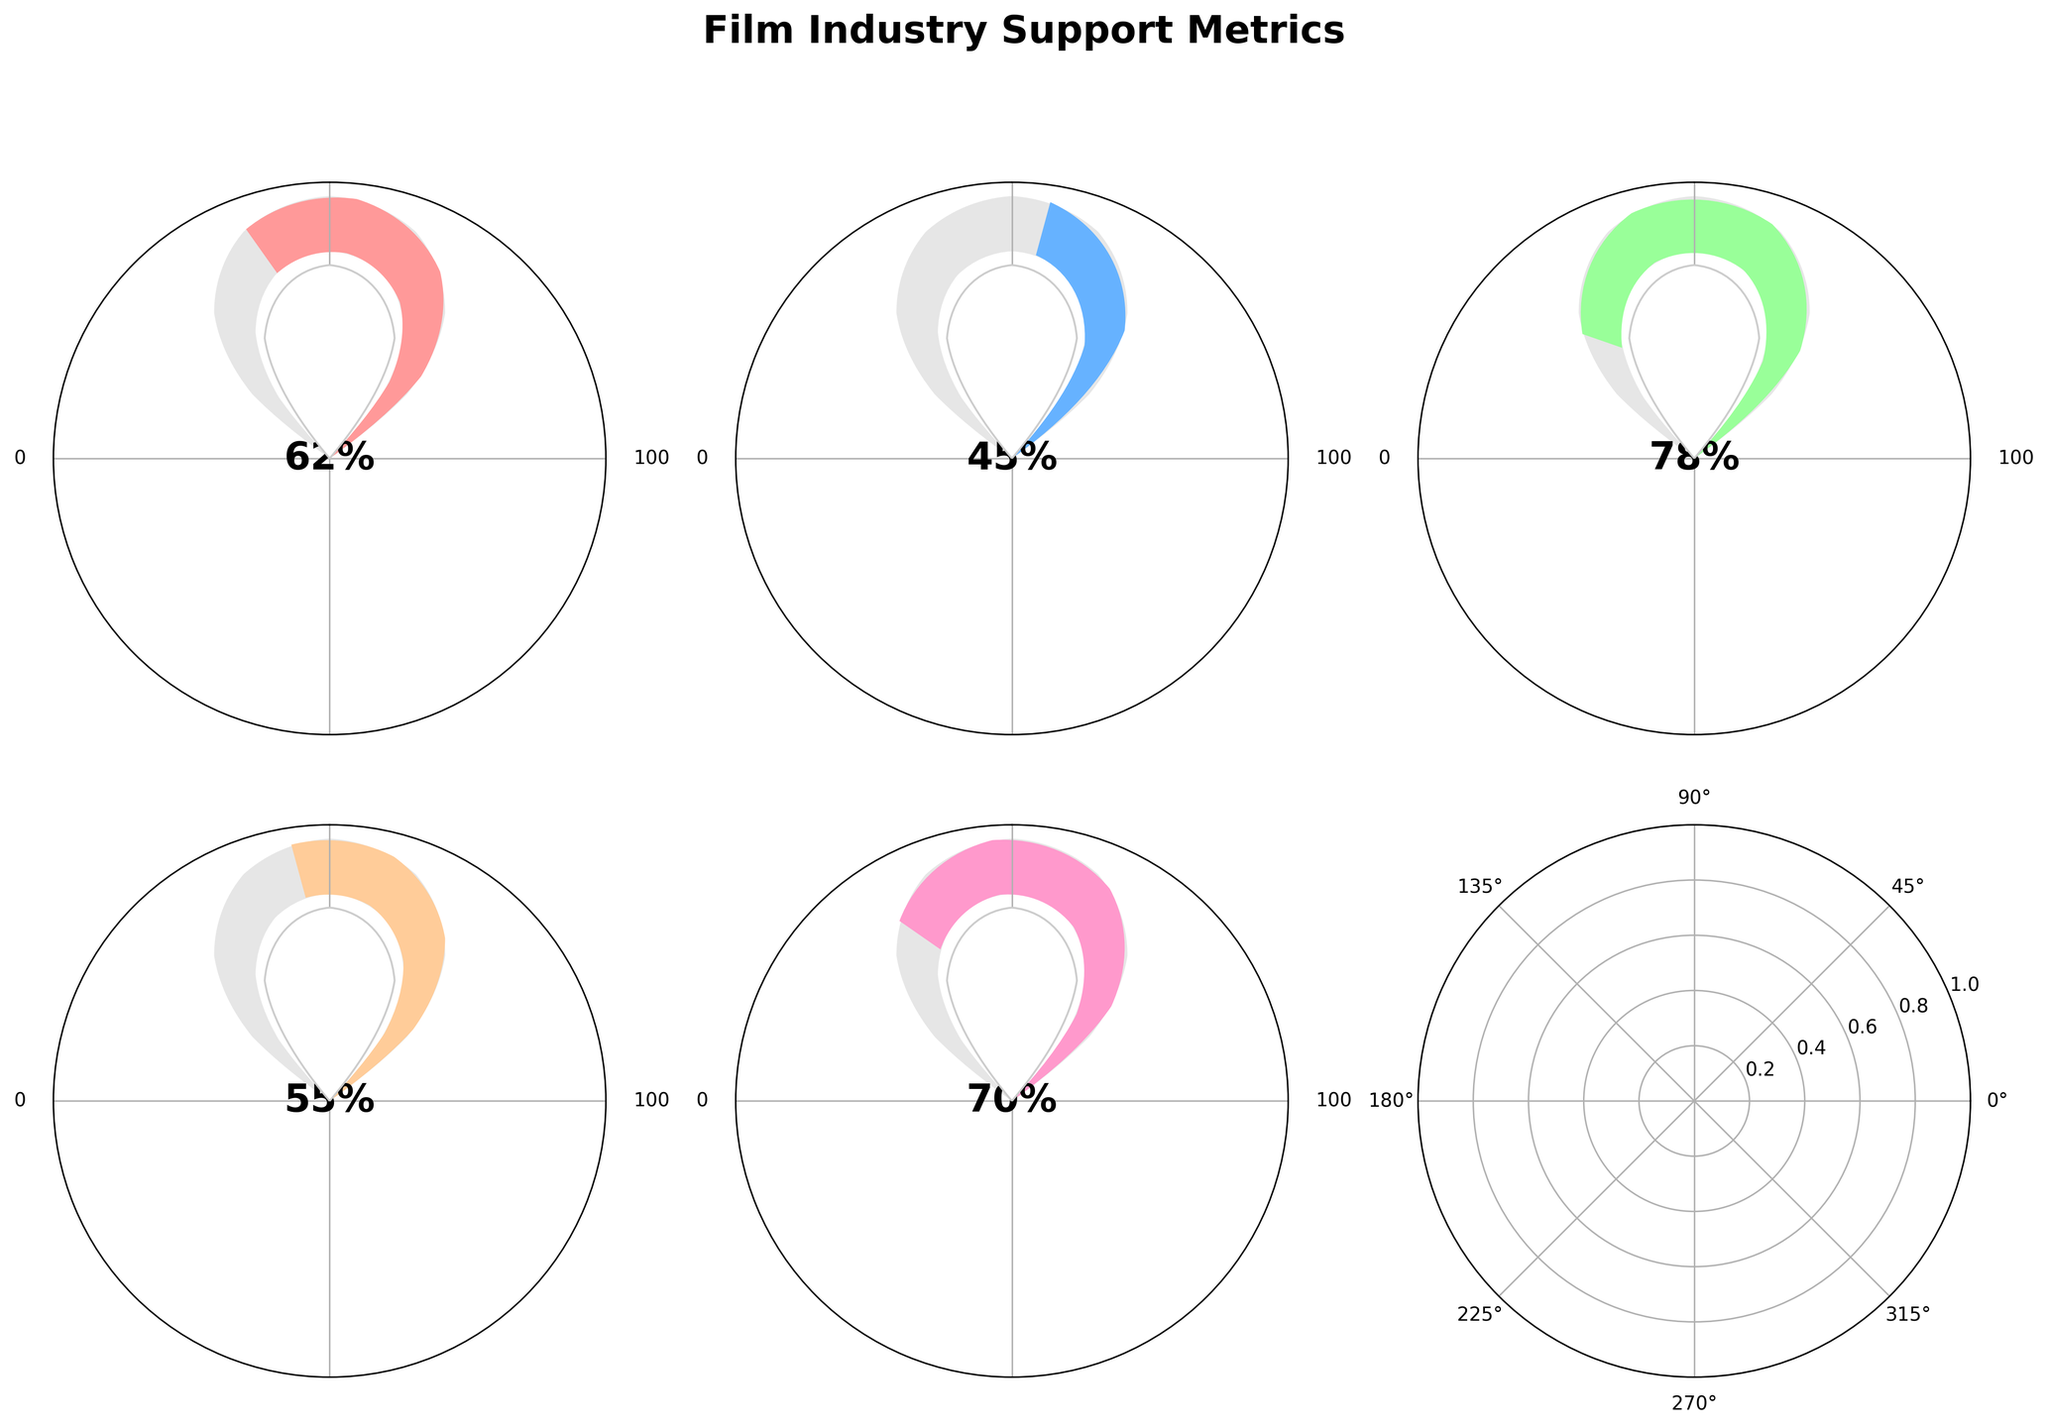What is the voter approval percentage for the senator's stance on film industry support? The gauge shows voter approval at 62%, indicated by the text inside the gauge.
Answer: 62% Which metric has the highest percentage and what is its value? The metric 'Film Industry Worker Support (%)' has the highest value of 78%, clearly shown by the length of the indicator and the percentage mentioned inside the gauge.
Answer: Film Industry Worker Support (%) at 78% How much higher is the 'Tourism Boost Expectation (%)' compared to the 'Independent Voter Support (%)'? 'Tourism Boost Expectation (%)' is 70%, and 'Independent Voter Support (%)' is 45%. The difference is 70% - 45% = 25%.
Answer: 25% What is the range of the voter approval ratings displayed in the gauges? The charts show values from 0% to 100%, as indicated by the values near the ends of each gauge.
Answer: 0% to 100% How does 'Overall Job Creation Perception (%)' compare to 'Independent Voter Support (%)'? 'Overall Job Creation Perception (%)' is 55%, while 'Independent Voter Support (%)' is 45%. 'Overall Job Creation Perception (%)' is 10% higher than 'Independent Voter Support (%)'.
Answer: Overall Job Creation Perception (%) is 10% higher What is the average percentage across all the metrics shown in the gauges? The percentages are 62%, 45%, 78%, 55%, and 70%. The average is (62 + 45 + 78 + 55 + 70) / 5 = 62%.
Answer: 62% Which metric shows the lowest support percentage, and what is its value? 'Independent Voter Support (%)' shows the lowest value at 45%, as displayed inside the gauge.
Answer: Independent Voter Support (%) at 45% What does the gauge indicate for 'Tourism Boost Expectation (%)'? The gauge shows 'Tourism Boost Expectation (%)' at 70%, as indicated by the label and the percentage displayed within the gauge.
Answer: 70% Compare the value of 'Film Industry Worker Support (%)' to the voter approval percentage. Which is higher and by how much? 'Film Industry Worker Support (%)' is 78%, and voter approval is 62%. The difference is 78% - 62% = 16%.
Answer: Film Industry Worker Support (%) is higher by 16% 